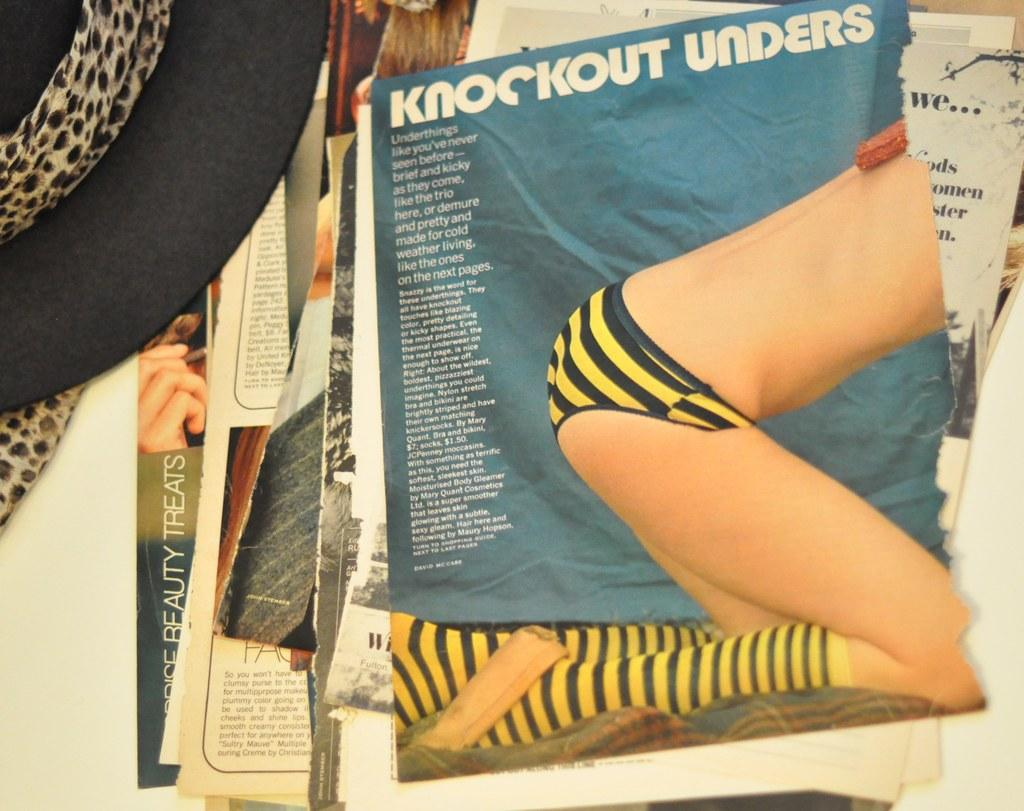<image>
Render a clear and concise summary of the photo. An advertisement for Knockout Unders torn out of a magazine 